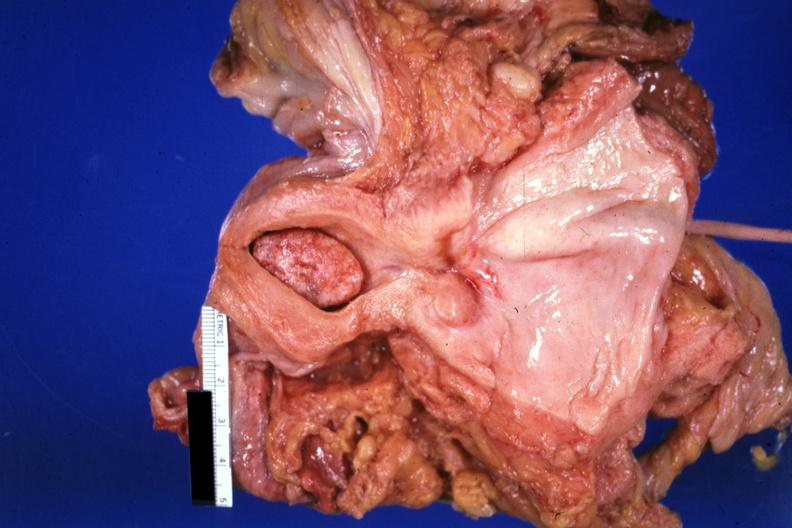s female reproductive present?
Answer the question using a single word or phrase. Yes 